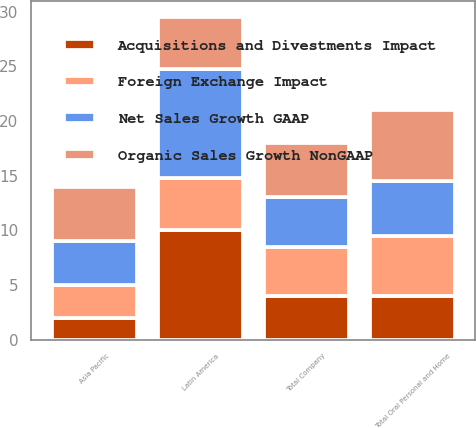Convert chart. <chart><loc_0><loc_0><loc_500><loc_500><stacked_bar_chart><ecel><fcel>Latin America<fcel>Asia Pacific<fcel>Total Oral Personal and Home<fcel>Total Company<nl><fcel>Organic Sales Growth NonGAAP<fcel>4.75<fcel>5<fcel>6.5<fcel>5<nl><fcel>Net Sales Growth GAAP<fcel>10<fcel>4<fcel>5<fcel>4.5<nl><fcel>Foreign Exchange Impact<fcel>4.75<fcel>3<fcel>5.5<fcel>4.5<nl><fcel>Acquisitions and Divestments Impact<fcel>10<fcel>2<fcel>4<fcel>4<nl></chart> 